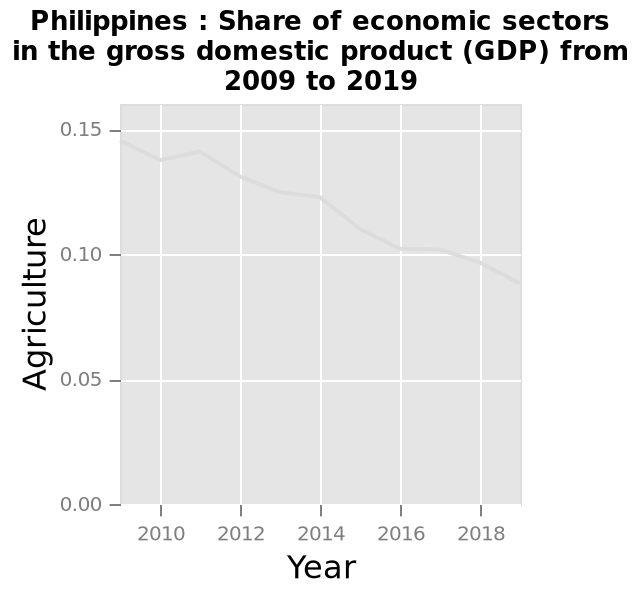<image>
When did the decline in the share of gross domestic product start? The decline in the share of gross domestic product started in 2010. What does the line plot represent? The line plot represents the share of economic sectors in the gross domestic product (GDP) of the Philippines from 2009 to 2019. What has been happening to the share of gross domestic product since 2010? There has been a steady decline in the share of gross domestic product since 2010. Does the bar graph represent the share of economic sectors in the gross domestic product (GDP) of the Philippines from 2009 to 2019? No.The line plot represents the share of economic sectors in the gross domestic product (GDP) of the Philippines from 2009 to 2019. 